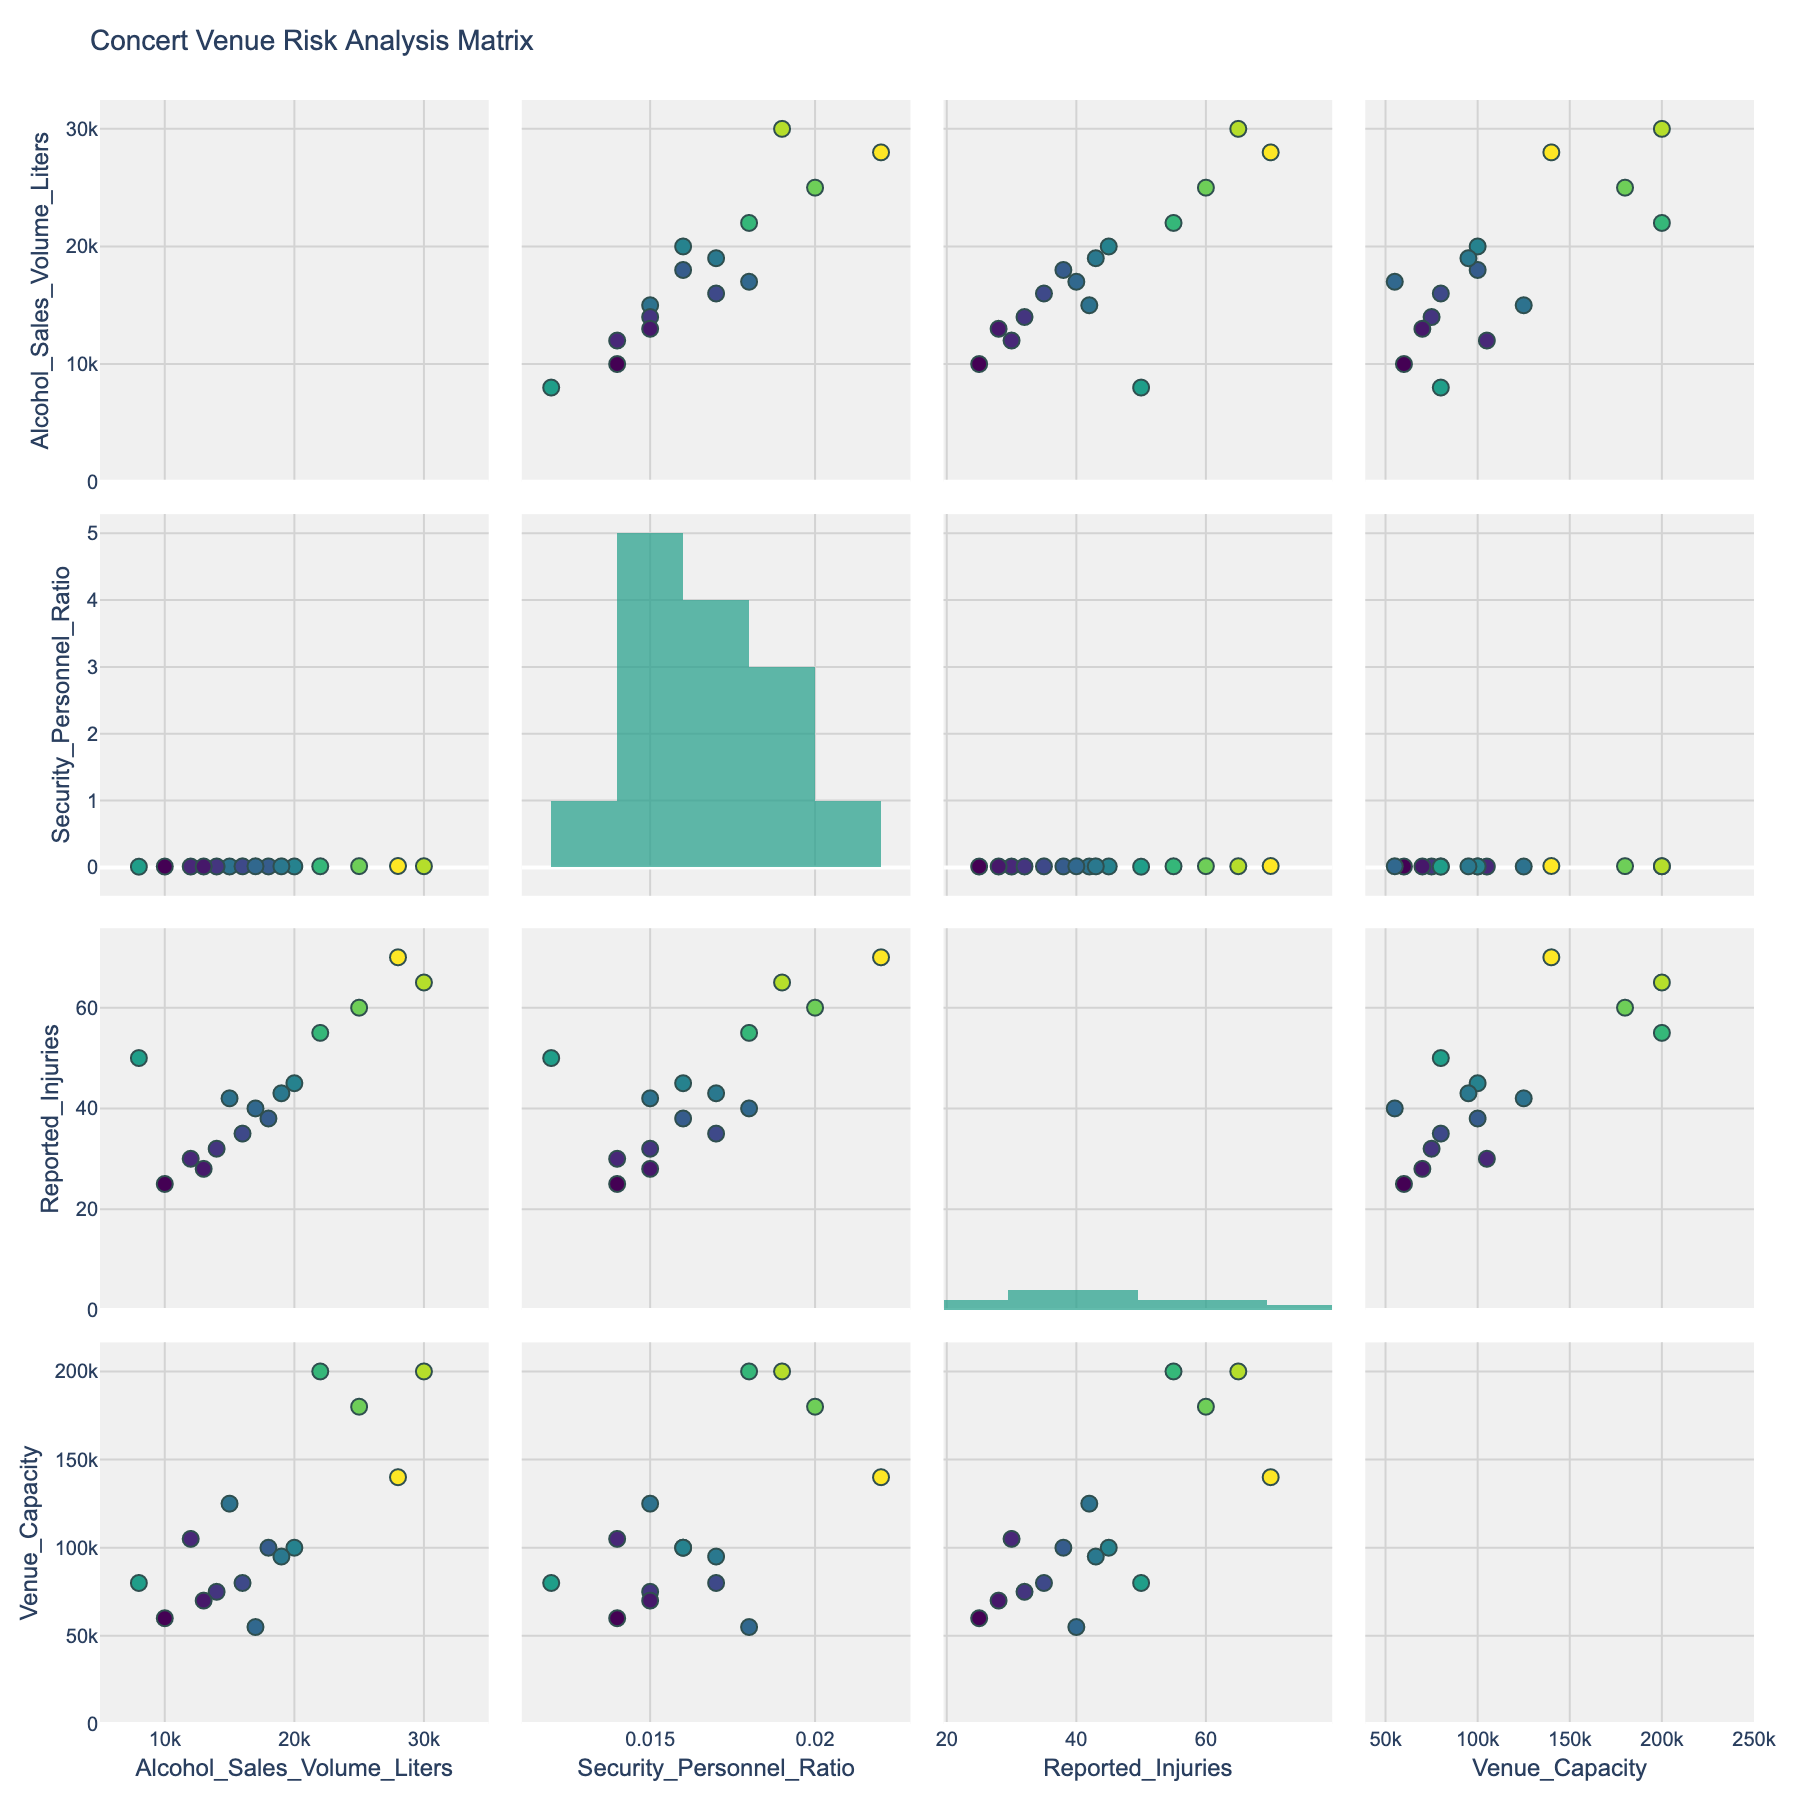How many different events are shown in the figure? Count the number of unique events in the dataset used for the scatterplot matrix.
Answer: 15 What variable has the highest histogram bar in the third row? The third row corresponds to 'Reported_Injuries'. The highest histogram bar is used to represent 'Reported_Injuries'.
Answer: Reported_Injuries Which event has the highest reported injuries and what is it? Look for the event associated with the highest value in the 'Reported_Injuries' column.
Answer: Electric Daisy Carnival, 70 Is there a positive trend between alcohol sales volume and reported injuries? Inspect the scatter plots of 'Alcohol_Sales_Volume_Liters' against 'Reported_Injuries'. If the points tend to rise together, it's a positive trend.
Answer: Yes Does "Rock in Rio" have a higher security personnel ratio compared to "Burning Man"? Find the values of 'Security_Personnel_Ratio' for both events and compare them.
Answer: Yes What's the average security personnel ratio for all events? Sum the security personnel ratios for all events and divide by the number of events: (0.015 + 0.018 + 0.016 + 0.020 + 0.014 + 0.017 + 0.015 + 0.022 + 0.016 + 0.019 + 0.014 + 0.015 + 0.018 + 0.012 + 0.017) / 15 = 0.0166
Answer: 0.0166 For events with more than 100 reported injuries, what is the range of security personnel ratios? Find the minimum and maximum security personnel ratios for events where 'Reported_Injuries' exceeds 100.
Answer: 0.014 to 0.020 Are larger venues generally associated with higher alcohol sales volumes? Assess the scatter plots of 'Venue_Capacity' against 'Alcohol_Sales_Volume_Liters'. Check if larger venue capacities correspond to higher alcohol sales volumes.
Answer: Yes What is the venue capacity of 'Bonnaroo'? Locate the 'Venue_Capacity' for the 'Bonnaroo' event.
Answer: 80000 Between 'Glastonbury' and 'Tomorrowland', which event has the higher alcohol sales volume and what is it? Compare the 'Alcohol_Sales_Volume_Liters' values for 'Glastonbury' and 'Tomorrowland'.
Answer: Tomorrowland, 25000 Of all the events, which has the lowest alcohol sales volume and what is the figure? Identify the event with the smallest 'Alcohol_Sales_Volume_Liters'.
Answer: Burning Man, 8000 